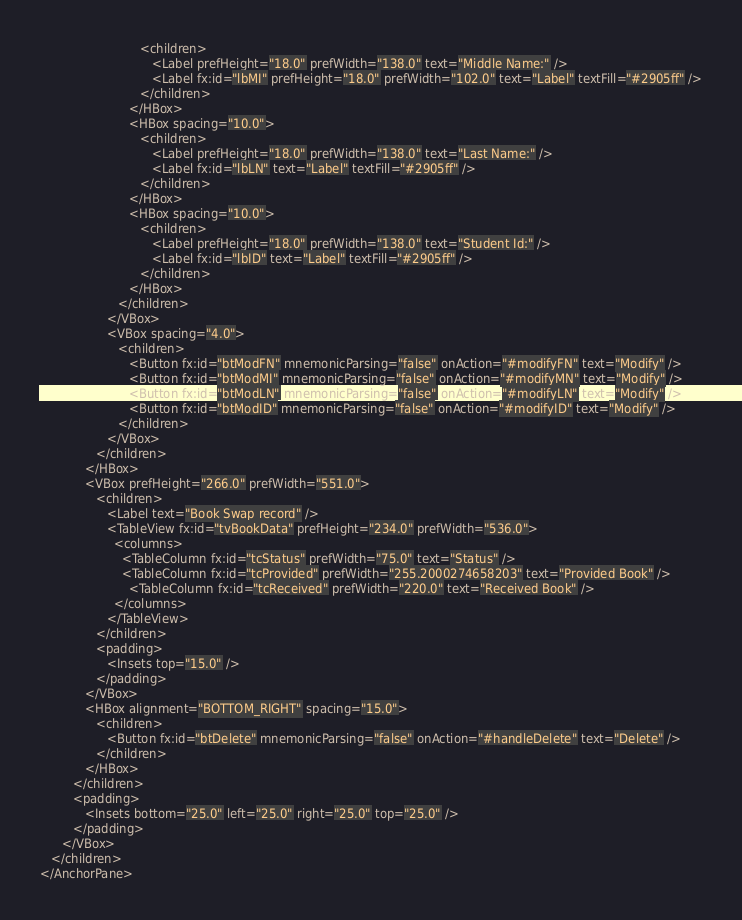Convert code to text. <code><loc_0><loc_0><loc_500><loc_500><_XML_>                           <children>
                              <Label prefHeight="18.0" prefWidth="138.0" text="Middle Name:" />
                              <Label fx:id="lbMI" prefHeight="18.0" prefWidth="102.0" text="Label" textFill="#2905ff" />
                           </children>
                        </HBox>
                        <HBox spacing="10.0">
                           <children>
                              <Label prefHeight="18.0" prefWidth="138.0" text="Last Name:" />
                              <Label fx:id="lbLN" text="Label" textFill="#2905ff" />
                           </children>
                        </HBox>
                        <HBox spacing="10.0">
                           <children>
                              <Label prefHeight="18.0" prefWidth="138.0" text="Student Id:" />
                              <Label fx:id="lbID" text="Label" textFill="#2905ff" />
                           </children>
                        </HBox>
                     </children>
                  </VBox>
                  <VBox spacing="4.0">
                     <children>
                        <Button fx:id="btModFN" mnemonicParsing="false" onAction="#modifyFN" text="Modify" />
                        <Button fx:id="btModMI" mnemonicParsing="false" onAction="#modifyMN" text="Modify" />
                        <Button fx:id="btModLN" mnemonicParsing="false" onAction="#modifyLN" text="Modify" />
                        <Button fx:id="btModID" mnemonicParsing="false" onAction="#modifyID" text="Modify" />
                     </children>
                  </VBox>
               </children>
            </HBox>
            <VBox prefHeight="266.0" prefWidth="551.0">
               <children>
                  <Label text="Book Swap record" />
                  <TableView fx:id="tvBookData" prefHeight="234.0" prefWidth="536.0">
                    <columns>
                      <TableColumn fx:id="tcStatus" prefWidth="75.0" text="Status" />
                      <TableColumn fx:id="tcProvided" prefWidth="255.2000274658203" text="Provided Book" />
                        <TableColumn fx:id="tcReceived" prefWidth="220.0" text="Received Book" />
                    </columns>
                  </TableView>
               </children>
               <padding>
                  <Insets top="15.0" />
               </padding>
            </VBox>
            <HBox alignment="BOTTOM_RIGHT" spacing="15.0">
               <children>
                  <Button fx:id="btDelete" mnemonicParsing="false" onAction="#handleDelete" text="Delete" />
               </children>
            </HBox>
         </children>
         <padding>
            <Insets bottom="25.0" left="25.0" right="25.0" top="25.0" />
         </padding>
      </VBox>
   </children>
</AnchorPane>
</code> 